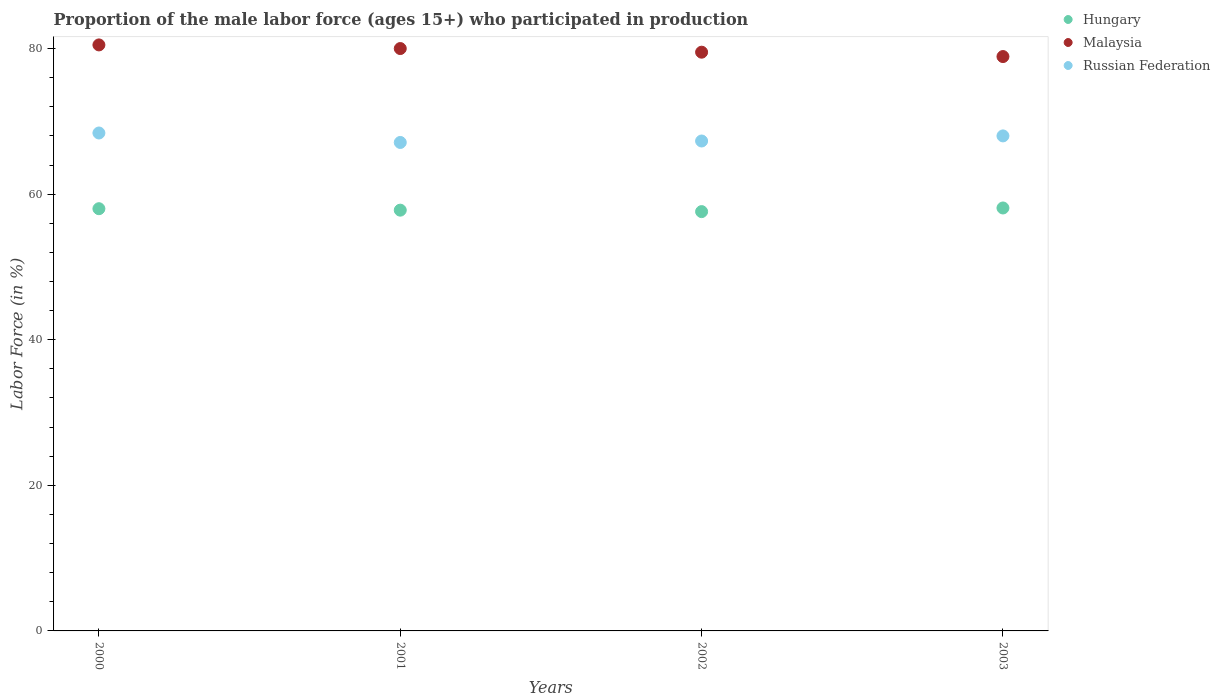What is the proportion of the male labor force who participated in production in Russian Federation in 2001?
Provide a short and direct response. 67.1. Across all years, what is the maximum proportion of the male labor force who participated in production in Malaysia?
Your response must be concise. 80.5. Across all years, what is the minimum proportion of the male labor force who participated in production in Hungary?
Ensure brevity in your answer.  57.6. In which year was the proportion of the male labor force who participated in production in Hungary maximum?
Make the answer very short. 2003. What is the total proportion of the male labor force who participated in production in Russian Federation in the graph?
Make the answer very short. 270.8. What is the difference between the proportion of the male labor force who participated in production in Malaysia in 2000 and that in 2001?
Ensure brevity in your answer.  0.5. What is the difference between the proportion of the male labor force who participated in production in Malaysia in 2003 and the proportion of the male labor force who participated in production in Russian Federation in 2000?
Offer a terse response. 10.5. What is the average proportion of the male labor force who participated in production in Hungary per year?
Your answer should be compact. 57.87. In the year 2001, what is the difference between the proportion of the male labor force who participated in production in Malaysia and proportion of the male labor force who participated in production in Hungary?
Your response must be concise. 22.2. In how many years, is the proportion of the male labor force who participated in production in Malaysia greater than 16 %?
Your response must be concise. 4. What is the ratio of the proportion of the male labor force who participated in production in Malaysia in 2001 to that in 2002?
Provide a short and direct response. 1.01. Is the proportion of the male labor force who participated in production in Malaysia in 2000 less than that in 2001?
Provide a short and direct response. No. Is the difference between the proportion of the male labor force who participated in production in Malaysia in 2001 and 2002 greater than the difference between the proportion of the male labor force who participated in production in Hungary in 2001 and 2002?
Make the answer very short. Yes. What is the difference between the highest and the second highest proportion of the male labor force who participated in production in Russian Federation?
Offer a terse response. 0.4. What is the difference between the highest and the lowest proportion of the male labor force who participated in production in Malaysia?
Your answer should be very brief. 1.6. In how many years, is the proportion of the male labor force who participated in production in Malaysia greater than the average proportion of the male labor force who participated in production in Malaysia taken over all years?
Provide a succinct answer. 2. Is it the case that in every year, the sum of the proportion of the male labor force who participated in production in Malaysia and proportion of the male labor force who participated in production in Russian Federation  is greater than the proportion of the male labor force who participated in production in Hungary?
Your response must be concise. Yes. Is the proportion of the male labor force who participated in production in Hungary strictly greater than the proportion of the male labor force who participated in production in Russian Federation over the years?
Offer a terse response. No. How many dotlines are there?
Your answer should be very brief. 3. How many years are there in the graph?
Keep it short and to the point. 4. What is the difference between two consecutive major ticks on the Y-axis?
Your answer should be compact. 20. Are the values on the major ticks of Y-axis written in scientific E-notation?
Make the answer very short. No. Does the graph contain any zero values?
Give a very brief answer. No. Does the graph contain grids?
Provide a succinct answer. No. Where does the legend appear in the graph?
Provide a succinct answer. Top right. How are the legend labels stacked?
Offer a terse response. Vertical. What is the title of the graph?
Give a very brief answer. Proportion of the male labor force (ages 15+) who participated in production. Does "Japan" appear as one of the legend labels in the graph?
Make the answer very short. No. What is the label or title of the X-axis?
Offer a very short reply. Years. What is the Labor Force (in %) of Malaysia in 2000?
Offer a terse response. 80.5. What is the Labor Force (in %) of Russian Federation in 2000?
Offer a very short reply. 68.4. What is the Labor Force (in %) in Hungary in 2001?
Give a very brief answer. 57.8. What is the Labor Force (in %) in Russian Federation in 2001?
Provide a short and direct response. 67.1. What is the Labor Force (in %) of Hungary in 2002?
Your answer should be very brief. 57.6. What is the Labor Force (in %) in Malaysia in 2002?
Your answer should be compact. 79.5. What is the Labor Force (in %) of Russian Federation in 2002?
Offer a very short reply. 67.3. What is the Labor Force (in %) in Hungary in 2003?
Your answer should be compact. 58.1. What is the Labor Force (in %) in Malaysia in 2003?
Provide a short and direct response. 78.9. What is the Labor Force (in %) in Russian Federation in 2003?
Offer a terse response. 68. Across all years, what is the maximum Labor Force (in %) in Hungary?
Provide a short and direct response. 58.1. Across all years, what is the maximum Labor Force (in %) of Malaysia?
Offer a terse response. 80.5. Across all years, what is the maximum Labor Force (in %) of Russian Federation?
Give a very brief answer. 68.4. Across all years, what is the minimum Labor Force (in %) of Hungary?
Offer a very short reply. 57.6. Across all years, what is the minimum Labor Force (in %) in Malaysia?
Your answer should be compact. 78.9. Across all years, what is the minimum Labor Force (in %) of Russian Federation?
Offer a terse response. 67.1. What is the total Labor Force (in %) of Hungary in the graph?
Offer a terse response. 231.5. What is the total Labor Force (in %) in Malaysia in the graph?
Make the answer very short. 318.9. What is the total Labor Force (in %) of Russian Federation in the graph?
Your answer should be compact. 270.8. What is the difference between the Labor Force (in %) in Russian Federation in 2000 and that in 2001?
Offer a terse response. 1.3. What is the difference between the Labor Force (in %) of Malaysia in 2000 and that in 2003?
Provide a succinct answer. 1.6. What is the difference between the Labor Force (in %) of Russian Federation in 2000 and that in 2003?
Ensure brevity in your answer.  0.4. What is the difference between the Labor Force (in %) in Russian Federation in 2001 and that in 2002?
Your answer should be compact. -0.2. What is the difference between the Labor Force (in %) of Hungary in 2001 and that in 2003?
Offer a very short reply. -0.3. What is the difference between the Labor Force (in %) in Malaysia in 2001 and that in 2003?
Ensure brevity in your answer.  1.1. What is the difference between the Labor Force (in %) in Russian Federation in 2002 and that in 2003?
Give a very brief answer. -0.7. What is the difference between the Labor Force (in %) of Hungary in 2000 and the Labor Force (in %) of Malaysia in 2001?
Provide a short and direct response. -22. What is the difference between the Labor Force (in %) in Malaysia in 2000 and the Labor Force (in %) in Russian Federation in 2001?
Ensure brevity in your answer.  13.4. What is the difference between the Labor Force (in %) of Hungary in 2000 and the Labor Force (in %) of Malaysia in 2002?
Keep it short and to the point. -21.5. What is the difference between the Labor Force (in %) of Hungary in 2000 and the Labor Force (in %) of Russian Federation in 2002?
Provide a succinct answer. -9.3. What is the difference between the Labor Force (in %) in Hungary in 2000 and the Labor Force (in %) in Malaysia in 2003?
Your answer should be compact. -20.9. What is the difference between the Labor Force (in %) in Hungary in 2001 and the Labor Force (in %) in Malaysia in 2002?
Provide a short and direct response. -21.7. What is the difference between the Labor Force (in %) of Hungary in 2001 and the Labor Force (in %) of Malaysia in 2003?
Give a very brief answer. -21.1. What is the difference between the Labor Force (in %) of Hungary in 2001 and the Labor Force (in %) of Russian Federation in 2003?
Offer a terse response. -10.2. What is the difference between the Labor Force (in %) in Malaysia in 2001 and the Labor Force (in %) in Russian Federation in 2003?
Offer a terse response. 12. What is the difference between the Labor Force (in %) in Hungary in 2002 and the Labor Force (in %) in Malaysia in 2003?
Your answer should be compact. -21.3. What is the difference between the Labor Force (in %) in Malaysia in 2002 and the Labor Force (in %) in Russian Federation in 2003?
Make the answer very short. 11.5. What is the average Labor Force (in %) of Hungary per year?
Keep it short and to the point. 57.88. What is the average Labor Force (in %) in Malaysia per year?
Give a very brief answer. 79.72. What is the average Labor Force (in %) in Russian Federation per year?
Provide a succinct answer. 67.7. In the year 2000, what is the difference between the Labor Force (in %) of Hungary and Labor Force (in %) of Malaysia?
Provide a short and direct response. -22.5. In the year 2000, what is the difference between the Labor Force (in %) of Hungary and Labor Force (in %) of Russian Federation?
Offer a terse response. -10.4. In the year 2001, what is the difference between the Labor Force (in %) in Hungary and Labor Force (in %) in Malaysia?
Your response must be concise. -22.2. In the year 2001, what is the difference between the Labor Force (in %) of Hungary and Labor Force (in %) of Russian Federation?
Ensure brevity in your answer.  -9.3. In the year 2001, what is the difference between the Labor Force (in %) in Malaysia and Labor Force (in %) in Russian Federation?
Your response must be concise. 12.9. In the year 2002, what is the difference between the Labor Force (in %) in Hungary and Labor Force (in %) in Malaysia?
Your answer should be compact. -21.9. In the year 2003, what is the difference between the Labor Force (in %) of Hungary and Labor Force (in %) of Malaysia?
Offer a very short reply. -20.8. What is the ratio of the Labor Force (in %) of Hungary in 2000 to that in 2001?
Keep it short and to the point. 1. What is the ratio of the Labor Force (in %) of Russian Federation in 2000 to that in 2001?
Keep it short and to the point. 1.02. What is the ratio of the Labor Force (in %) of Malaysia in 2000 to that in 2002?
Offer a terse response. 1.01. What is the ratio of the Labor Force (in %) of Russian Federation in 2000 to that in 2002?
Make the answer very short. 1.02. What is the ratio of the Labor Force (in %) in Malaysia in 2000 to that in 2003?
Your response must be concise. 1.02. What is the ratio of the Labor Force (in %) of Russian Federation in 2000 to that in 2003?
Ensure brevity in your answer.  1.01. What is the ratio of the Labor Force (in %) in Malaysia in 2001 to that in 2002?
Give a very brief answer. 1.01. What is the ratio of the Labor Force (in %) of Hungary in 2001 to that in 2003?
Keep it short and to the point. 0.99. What is the ratio of the Labor Force (in %) of Malaysia in 2001 to that in 2003?
Your answer should be very brief. 1.01. What is the ratio of the Labor Force (in %) of Malaysia in 2002 to that in 2003?
Your answer should be very brief. 1.01. What is the difference between the highest and the second highest Labor Force (in %) of Hungary?
Provide a succinct answer. 0.1. What is the difference between the highest and the second highest Labor Force (in %) of Russian Federation?
Provide a short and direct response. 0.4. What is the difference between the highest and the lowest Labor Force (in %) in Hungary?
Offer a very short reply. 0.5. What is the difference between the highest and the lowest Labor Force (in %) of Malaysia?
Give a very brief answer. 1.6. What is the difference between the highest and the lowest Labor Force (in %) in Russian Federation?
Provide a succinct answer. 1.3. 